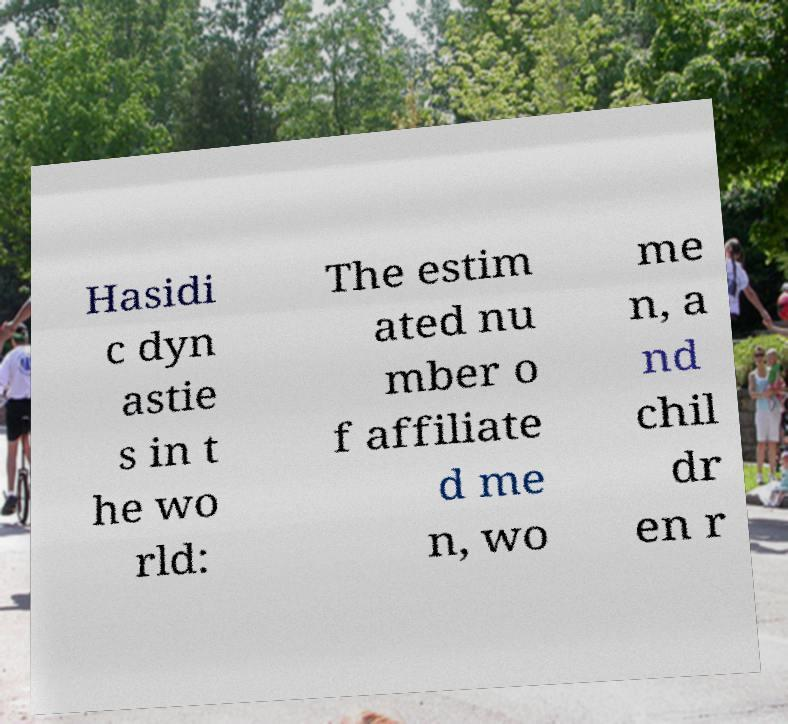Can you read and provide the text displayed in the image?This photo seems to have some interesting text. Can you extract and type it out for me? Hasidi c dyn astie s in t he wo rld: The estim ated nu mber o f affiliate d me n, wo me n, a nd chil dr en r 